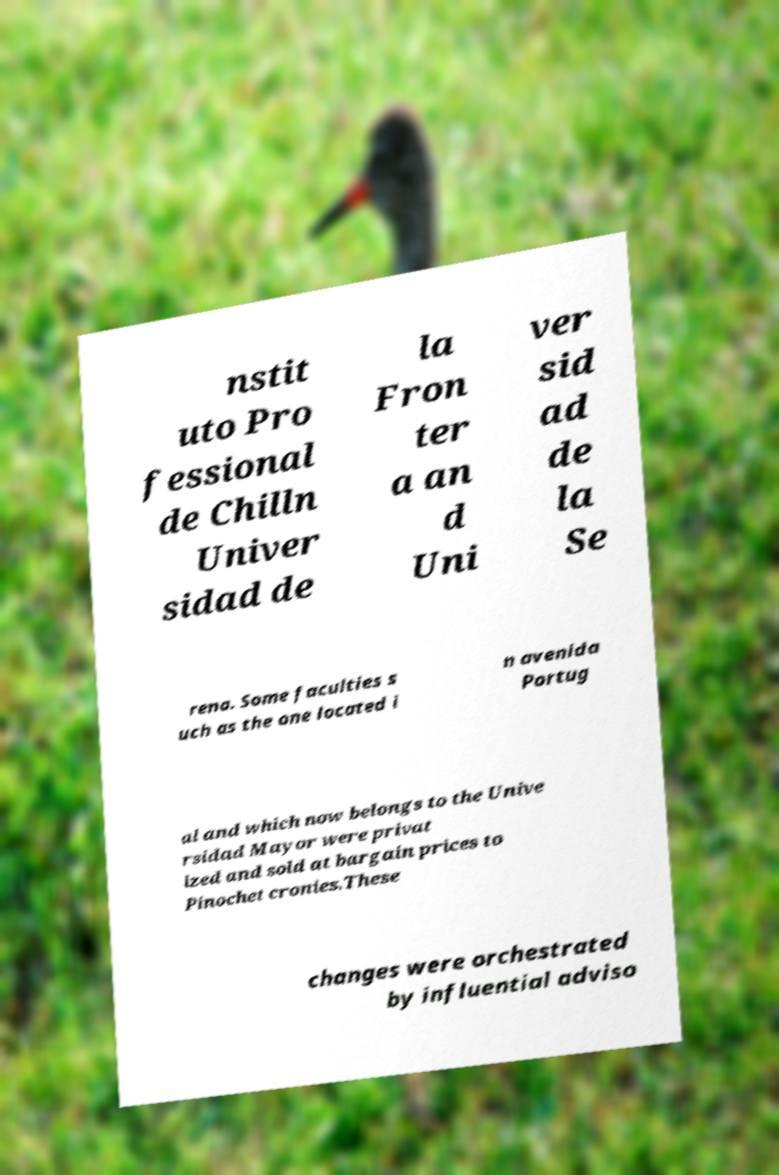For documentation purposes, I need the text within this image transcribed. Could you provide that? nstit uto Pro fessional de Chilln Univer sidad de la Fron ter a an d Uni ver sid ad de la Se rena. Some faculties s uch as the one located i n avenida Portug al and which now belongs to the Unive rsidad Mayor were privat ized and sold at bargain prices to Pinochet cronies.These changes were orchestrated by influential adviso 